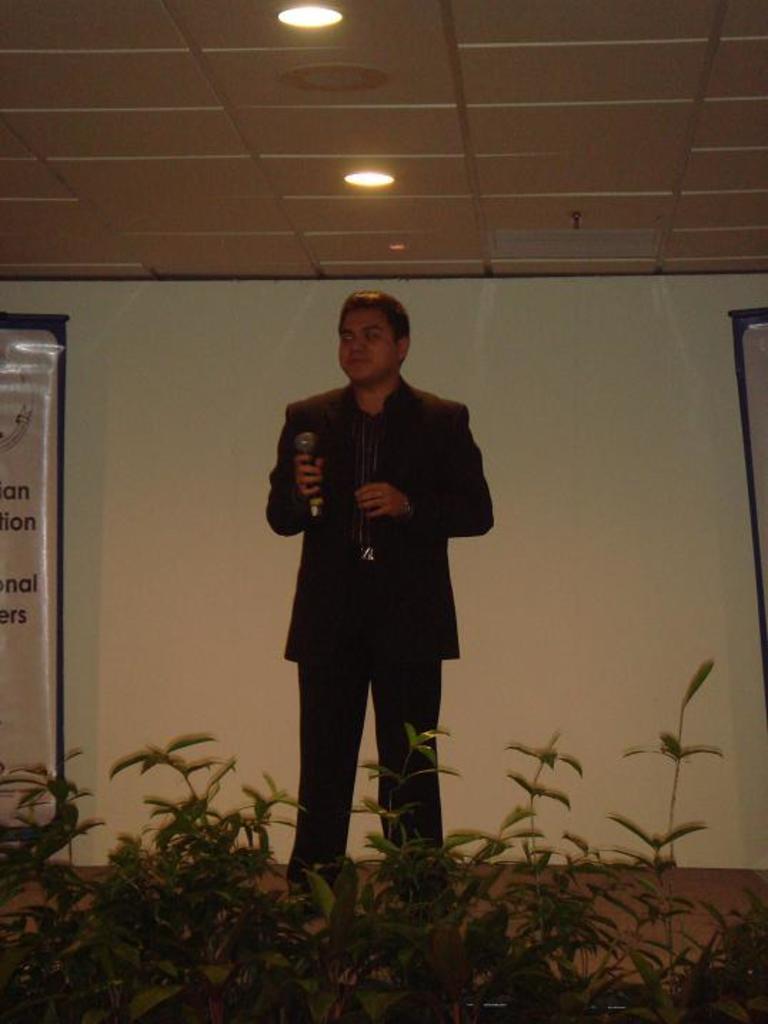Can you describe this image briefly? In this image in the center there is one person who is standing, and at the bottom there are some plants and a floor and on the left side there is one board. On the right side also there is one board, and in the background there is wall. At the top there is ceiling and some lights. 